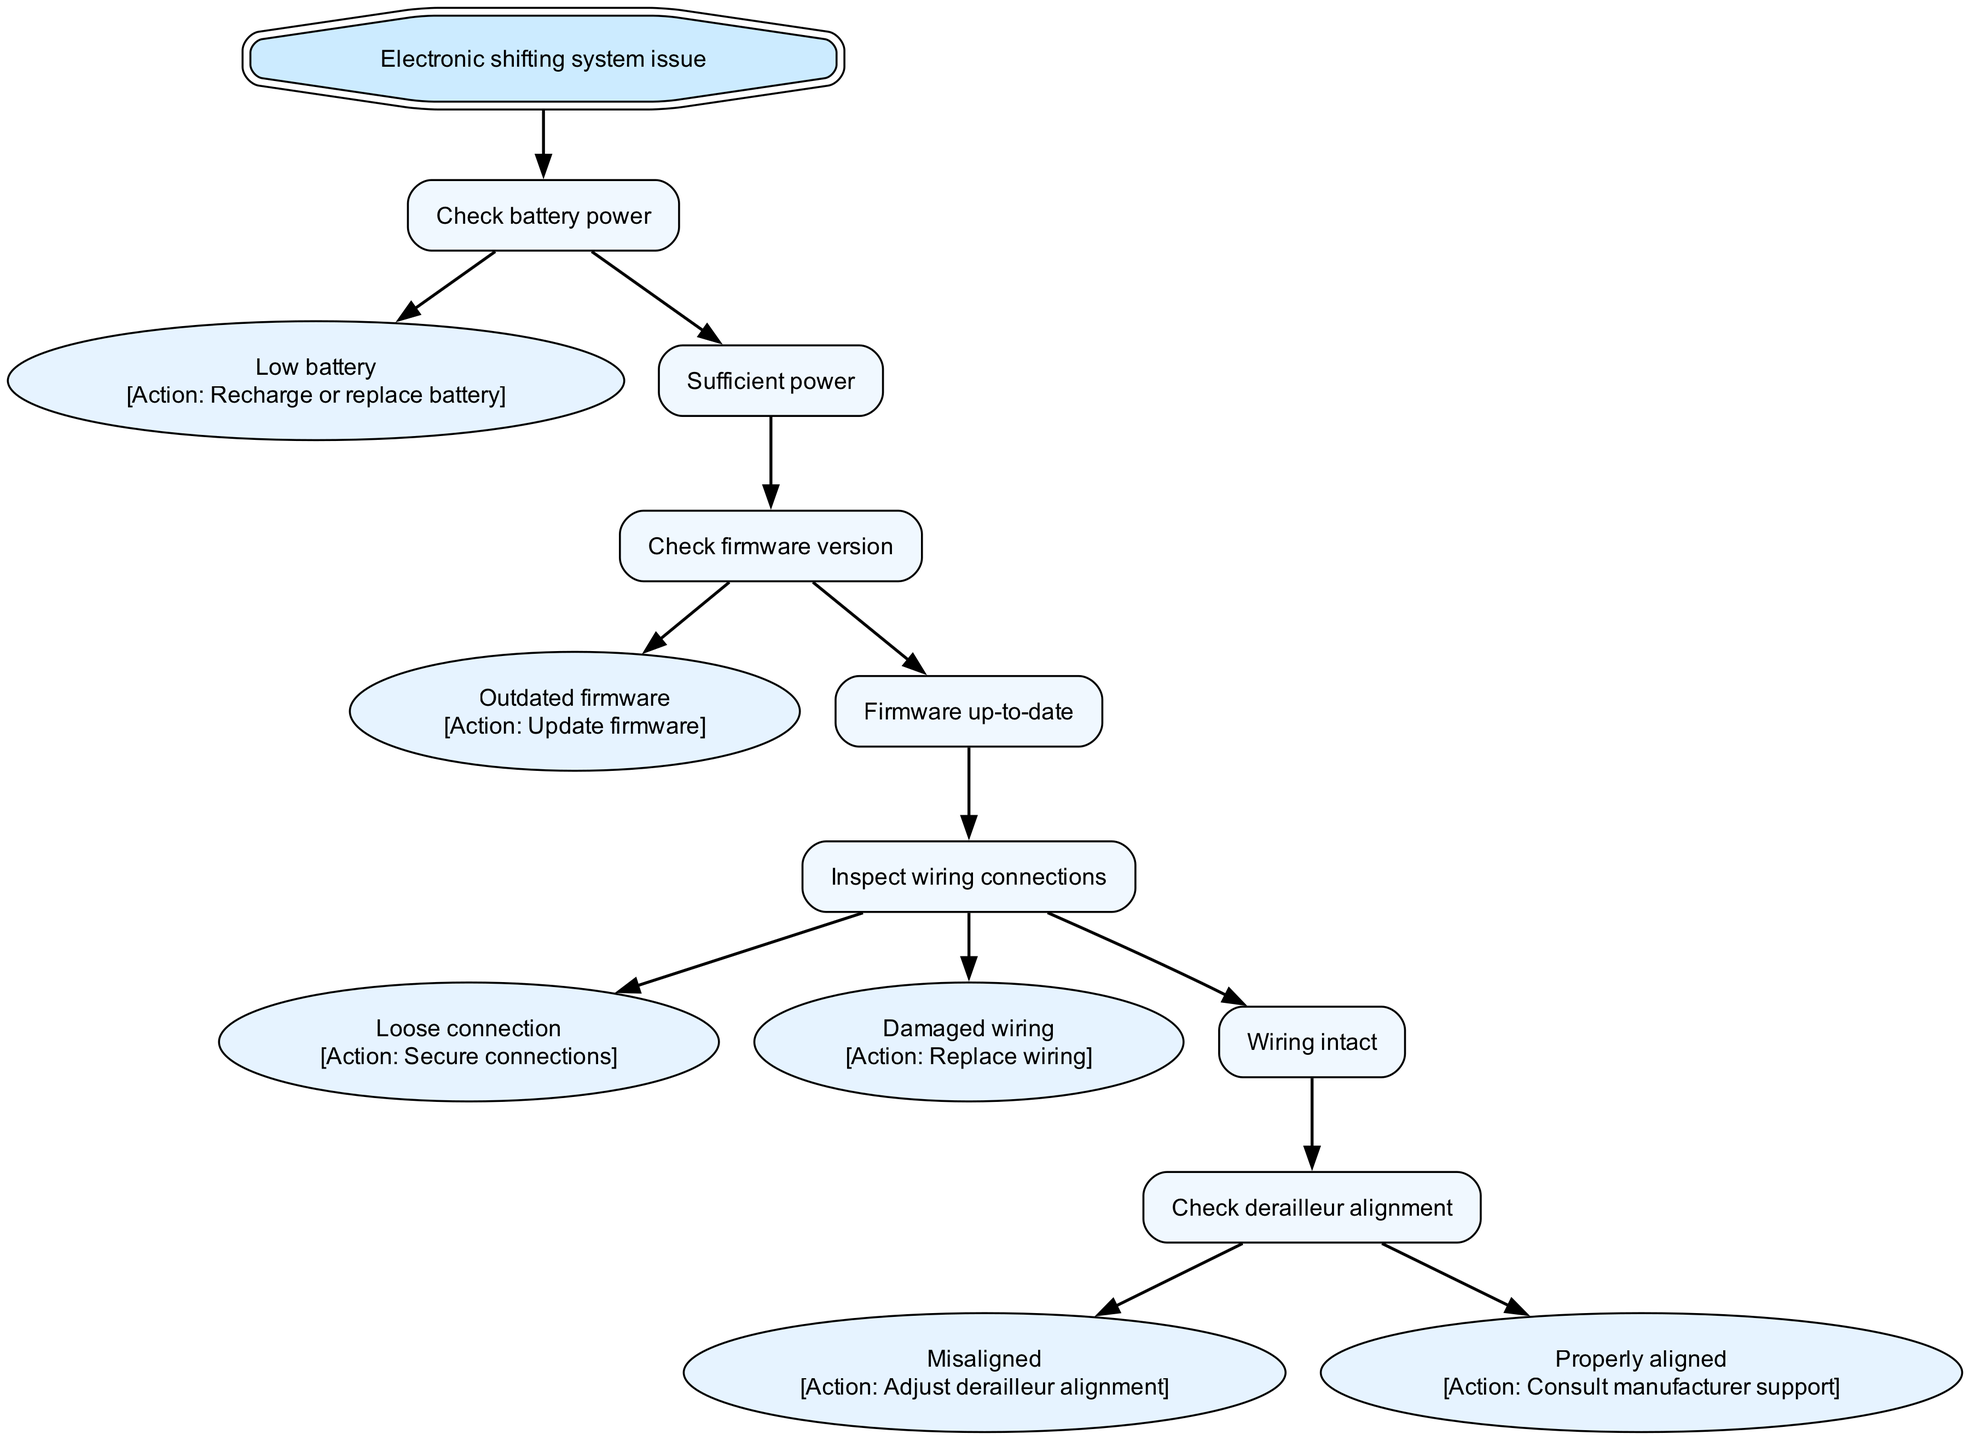What is the first step to troubleshoot an electronic shifting system? The first step is to check the battery power. It is the root node, indicating it starts the troubleshooting process.
Answer: Check battery power How many actions are linked to the "Check wiring connections" node? There are three actions linked to the "Inspect wiring connections" node: Secure connections, Replace wiring, and Consult manufacturer support.
Answer: Three actions What should be done if the firmware version is outdated? If the firmware version is outdated, the action is to update the firmware. This is specified directly in the node.
Answer: Update firmware What happens if there's a loose connection during the inspection? If there is a loose connection during the inspection of wiring connections, the action to take is to secure the connections. This is explicitly mentioned in the corresponding node.
Answer: Secure connections If the battery has sufficient power, what is the next check? If the battery has sufficient power, the next check is to look at the firmware version to ensure it is up-to-date. This follows logically from the flow of the decision tree.
Answer: Check firmware version How is the relationship between the "Damaged wiring" and the actions to take? The "Damaged wiring" node is related to an action that states to replace the wiring. This represents a direct link from the issue to the resolution in the diagram.
Answer: Replace wiring What node follows after confirming proper derailleur alignment? After confirming proper derailleur alignment, the next step is to consult manufacturer support. This is a direct output from the decision path in the diagram.
Answer: Consult manufacturer support What are the two types of conditions under wiring inspection? The two conditions under wiring inspection are "Loose connection" and "Damaged wiring." These indicate the potential issues that can arise from inspecting the wiring connections.
Answer: Loose connection and Damaged wiring How many children does the "Sufficient power" node have? The "Sufficient power" node has one child, which is "Check firmware version." This shows that the next step in troubleshooting only follows the “Sufficient power” path.
Answer: One child 